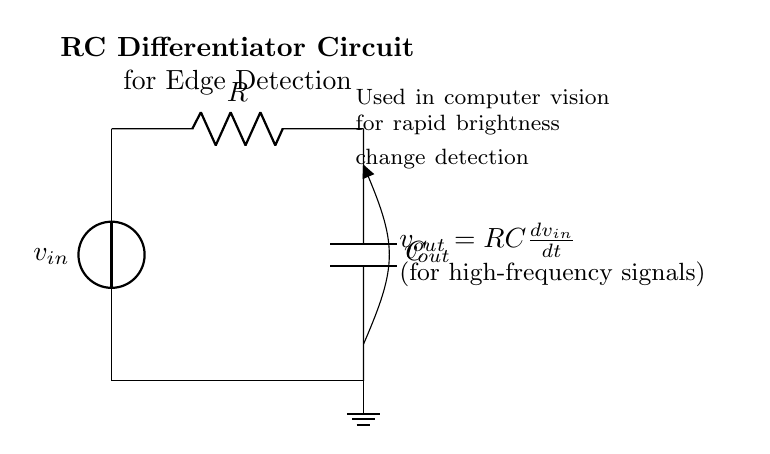What is the input component of the circuit? The input component is the voltage source, which provides the input signal to the circuit.
Answer: voltage source What are the two main components in this RC differentiator circuit? The two main components are the resistor and the capacitor, which are crucial for the circuit's operation in differentiating input signals.
Answer: resistor and capacitor What is the output voltage equation for this circuit? The output voltage equation is derived from the relationship between the components and is expressed as v out equals RC times the derivative of v in with respect to time.
Answer: v out equals RC times dv in over dt Why is this circuit used for edge detection in computer vision? This circuit is used for edge detection because it can respond quickly to rapid changes in input voltage, making it ideal for detecting edges in images.
Answer: rapid brightness change detection What happens if the input frequency increases? If the input frequency increases, the output voltage will also increase due to the differentiating nature of the circuit, leading to more pronounced output for high-frequency signals.
Answer: increases output voltage What does the capacitor do in the circuit? The capacitor stores and releases electrical energy, allowing the circuit to respond to changes in voltage over time, effectively differentiating the input signal.
Answer: stores and releases energy What is the role of the resistor in this RC differentiator circuit? The resistor limits the current flow and, together with the capacitor, defines the time constant of the circuit, influencing how quickly the circuit responds to changes in input voltage.
Answer: limits current flow 